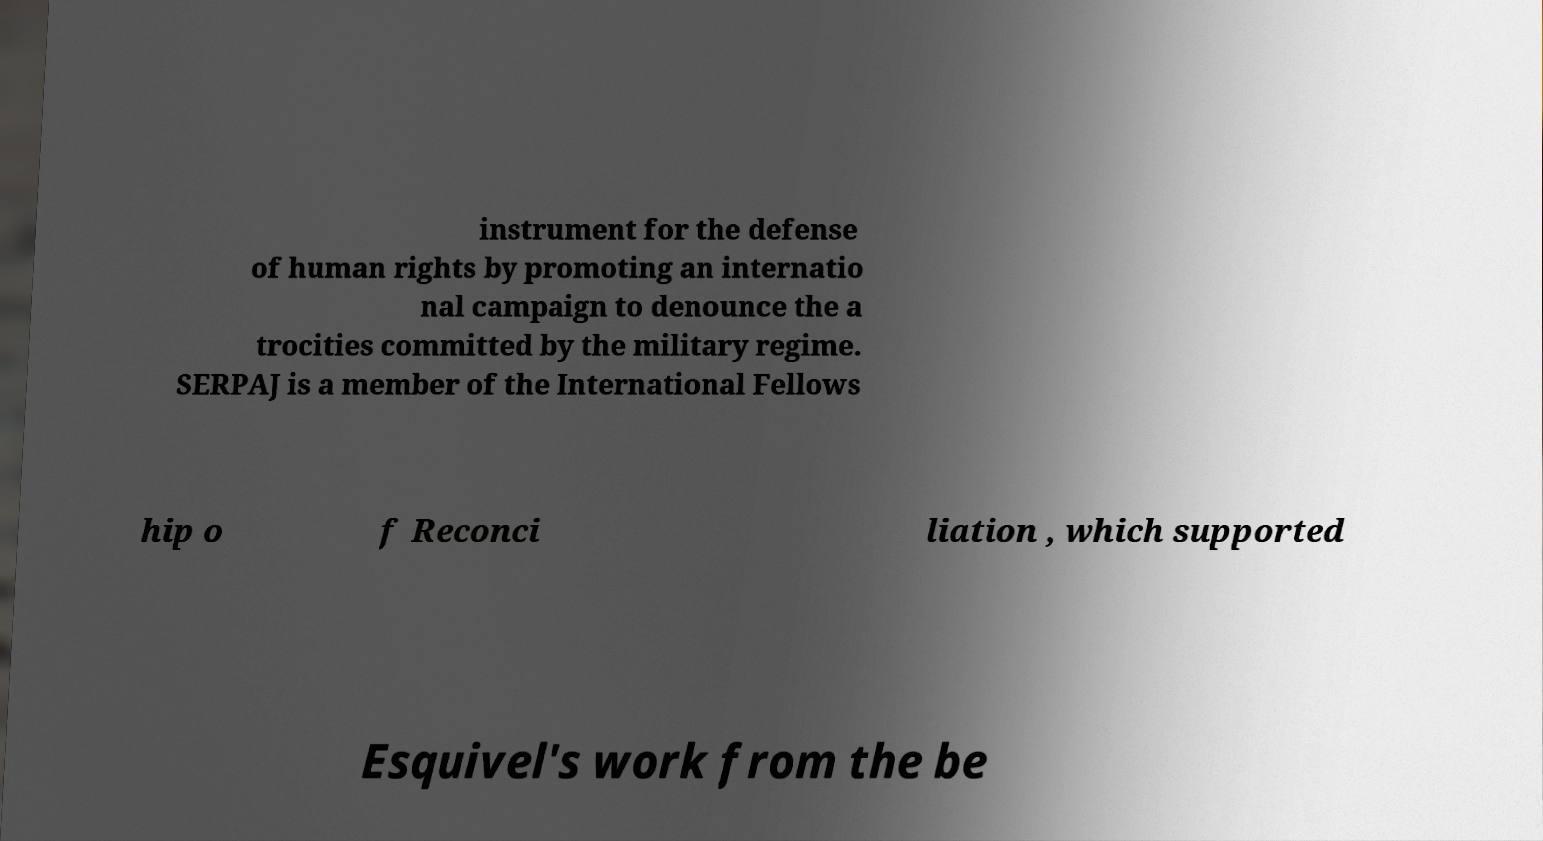Could you assist in decoding the text presented in this image and type it out clearly? instrument for the defense of human rights by promoting an internatio nal campaign to denounce the a trocities committed by the military regime. SERPAJ is a member of the International Fellows hip o f Reconci liation , which supported Esquivel's work from the be 